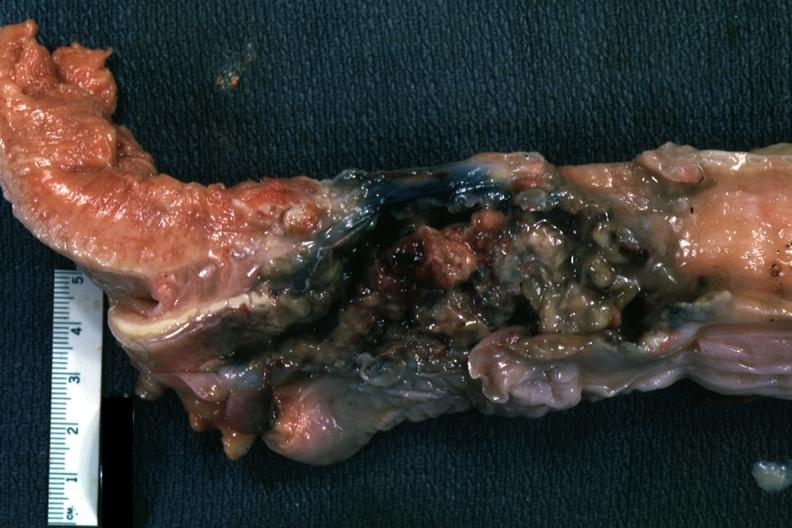what does this image show?
Answer the question using a single word or phrase. Larynx is mass of necrotic tissue 